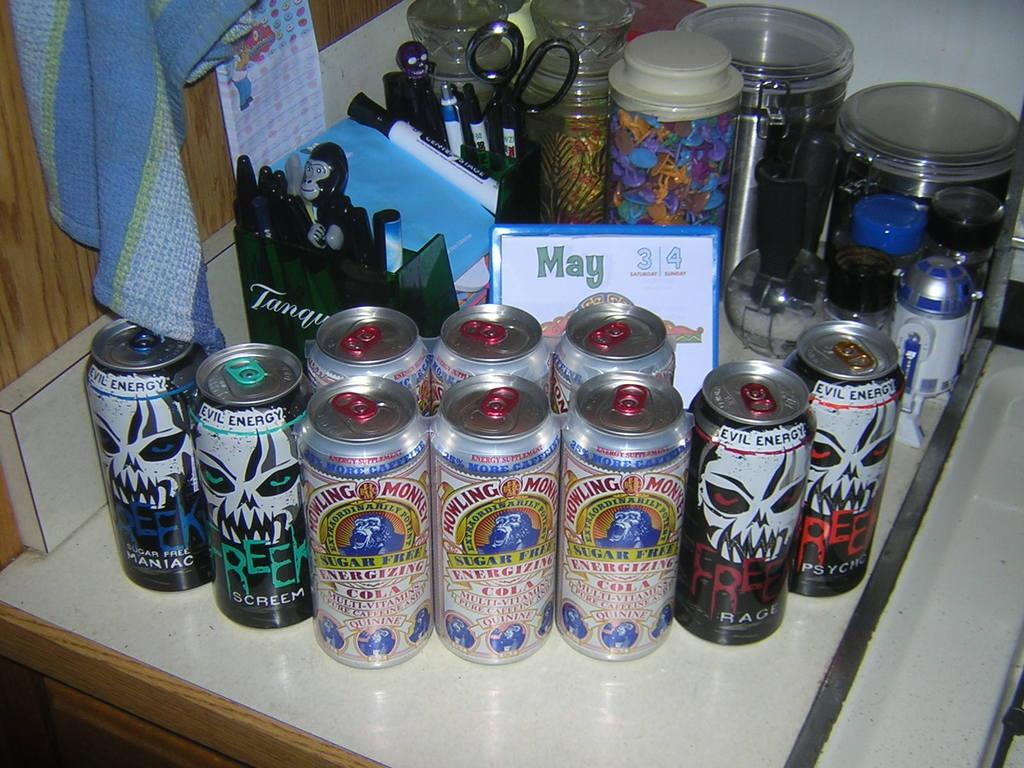<image>
Provide a brief description of the given image. Several cans of beer sit on a counter on the weekend of May 3rd and 4th. 